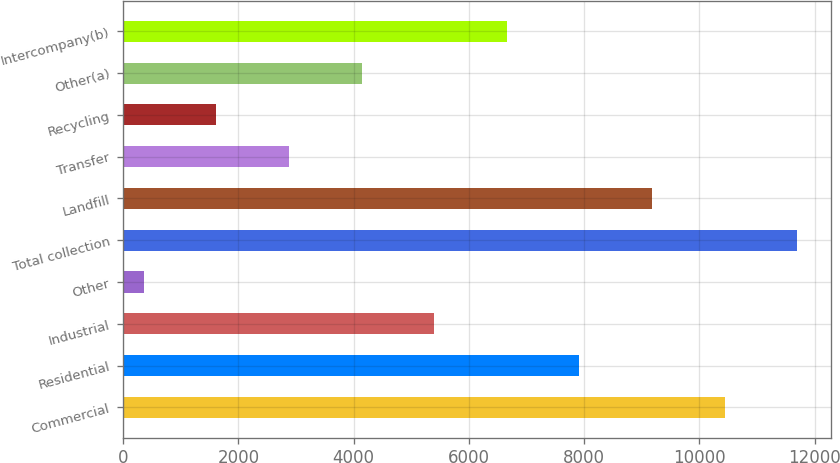Convert chart. <chart><loc_0><loc_0><loc_500><loc_500><bar_chart><fcel>Commercial<fcel>Residential<fcel>Industrial<fcel>Other<fcel>Total collection<fcel>Landfill<fcel>Transfer<fcel>Recycling<fcel>Other(a)<fcel>Intercompany(b)<nl><fcel>10440<fcel>7919<fcel>5398<fcel>356<fcel>11700.5<fcel>9179.5<fcel>2877<fcel>1616.5<fcel>4137.5<fcel>6658.5<nl></chart> 